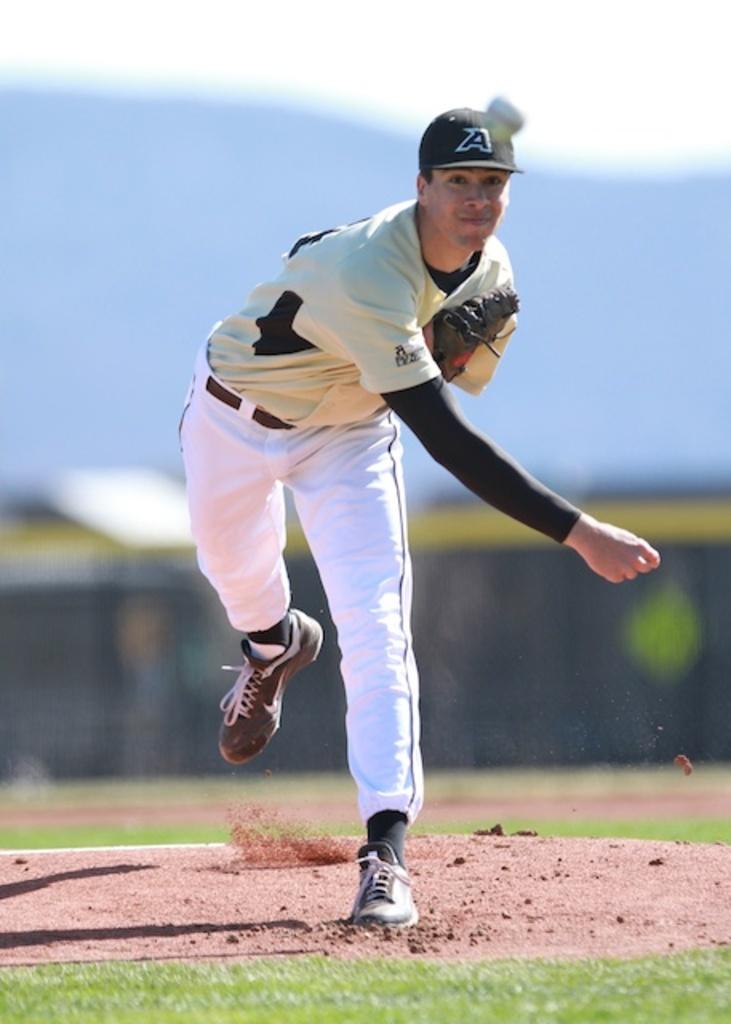What letter is on his hat?
Keep it short and to the point. A. 